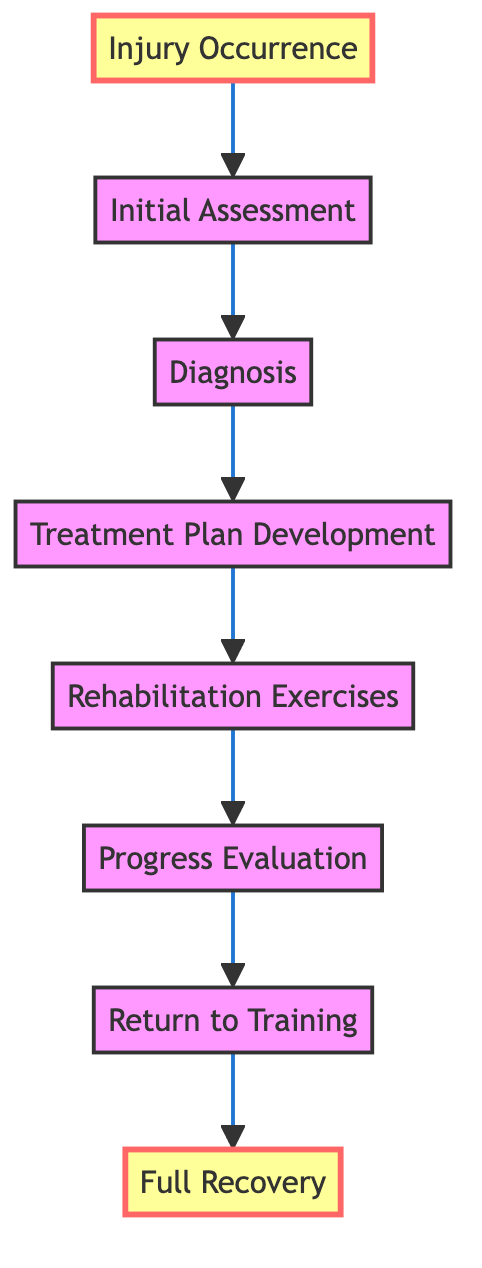What is the first step after Injury Occurrence? The diagram shows a directed flow starting from "Injury Occurrence" to "Initial Assessment", indicating that the first step following an injury is the initial assessment of the injury.
Answer: Initial Assessment How many nodes are there in the diagram? The diagram lists 8 nodes representing stages in the injury management and rehabilitation process, including tasks ranging from injury occurrence to full recovery.
Answer: 8 Which step is directly after Rehabilitation Exercises? According to the diagram, the step that follows "Rehabilitation Exercises" is "Progress Evaluation", illustrated by the directed edge connecting these two nodes.
Answer: Progress Evaluation What is the last step in the rehabilitation process? The end stage of the rehabilitation process, as per the flow in the diagram, is "Full Recovery", which completes the directed path starting from an injury occurrence.
Answer: Full Recovery What is the relationship between Diagnosis and Treatment Plan Development? There is a directed edge from "Diagnosis" to "Treatment Plan Development", indicating that after a diagnosis is made, the next step is to develop a treatment plan.
Answer: Development What step comes before Return to Training? The diagram indicates that "Progress Evaluation" occurs right before "Return to Training", with a directed relationship leading into the return phase.
Answer: Progress Evaluation How many edges are in the diagram? The diagram contains 7 edges which connect the various nodes, illustrating the progression through the steps in the rehabilitation process.
Answer: 7 What are the two highlighted nodes in the diagram? The diagram visually highlights "Injury Occurrence" and "Full Recovery" indicating these two points are pivotal in the entire process from start to finish.
Answer: Injury Occurrence, Full Recovery What process step is the third in the sequence? The directed flow shows that the third step following the injury occurrence is "Diagnosis", linking the nodes sequentially from the start of the process.
Answer: Diagnosis 